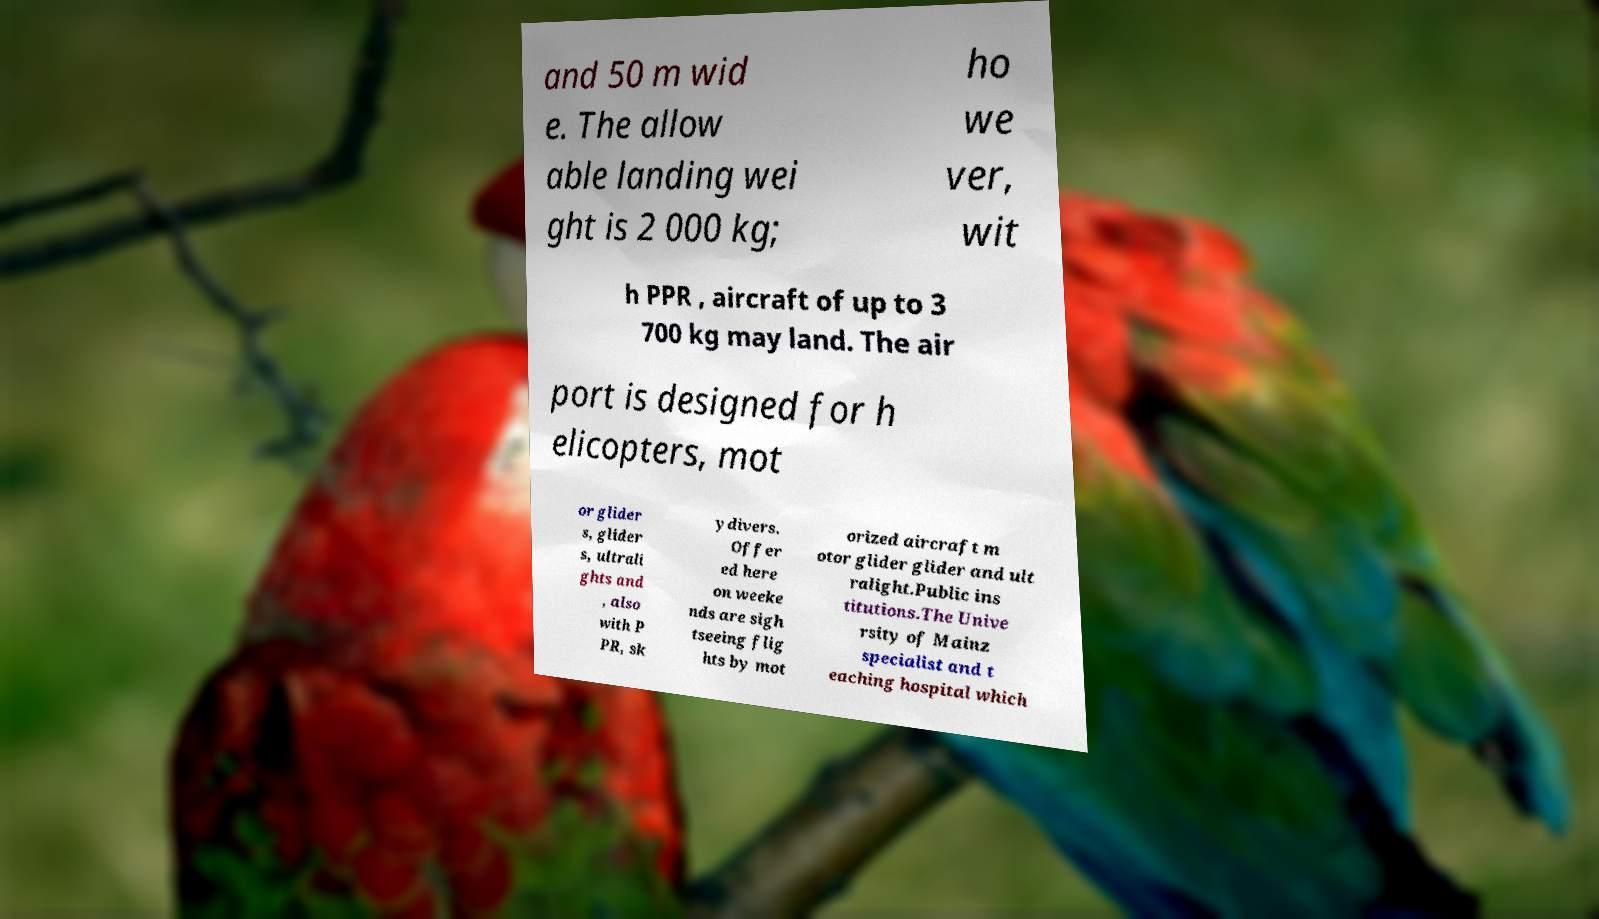What messages or text are displayed in this image? I need them in a readable, typed format. and 50 m wid e. The allow able landing wei ght is 2 000 kg; ho we ver, wit h PPR , aircraft of up to 3 700 kg may land. The air port is designed for h elicopters, mot or glider s, glider s, ultrali ghts and , also with P PR, sk ydivers. Offer ed here on weeke nds are sigh tseeing flig hts by mot orized aircraft m otor glider glider and ult ralight.Public ins titutions.The Unive rsity of Mainz specialist and t eaching hospital which 